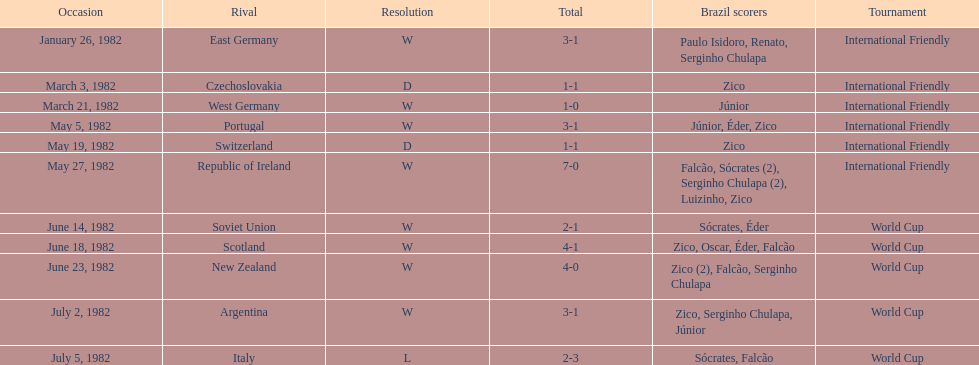What are all the dates of games in 1982 in brazilian football? January 26, 1982, March 3, 1982, March 21, 1982, May 5, 1982, May 19, 1982, May 27, 1982, June 14, 1982, June 18, 1982, June 23, 1982, July 2, 1982, July 5, 1982. Which of these dates is at the top of the chart? January 26, 1982. 